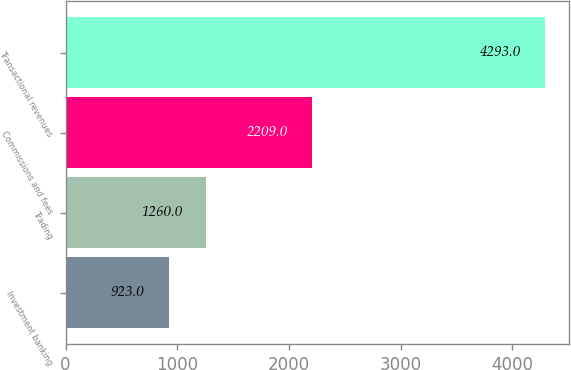Convert chart to OTSL. <chart><loc_0><loc_0><loc_500><loc_500><bar_chart><fcel>Investment banking<fcel>Trading<fcel>Commissions and fees<fcel>Transactional revenues<nl><fcel>923<fcel>1260<fcel>2209<fcel>4293<nl></chart> 